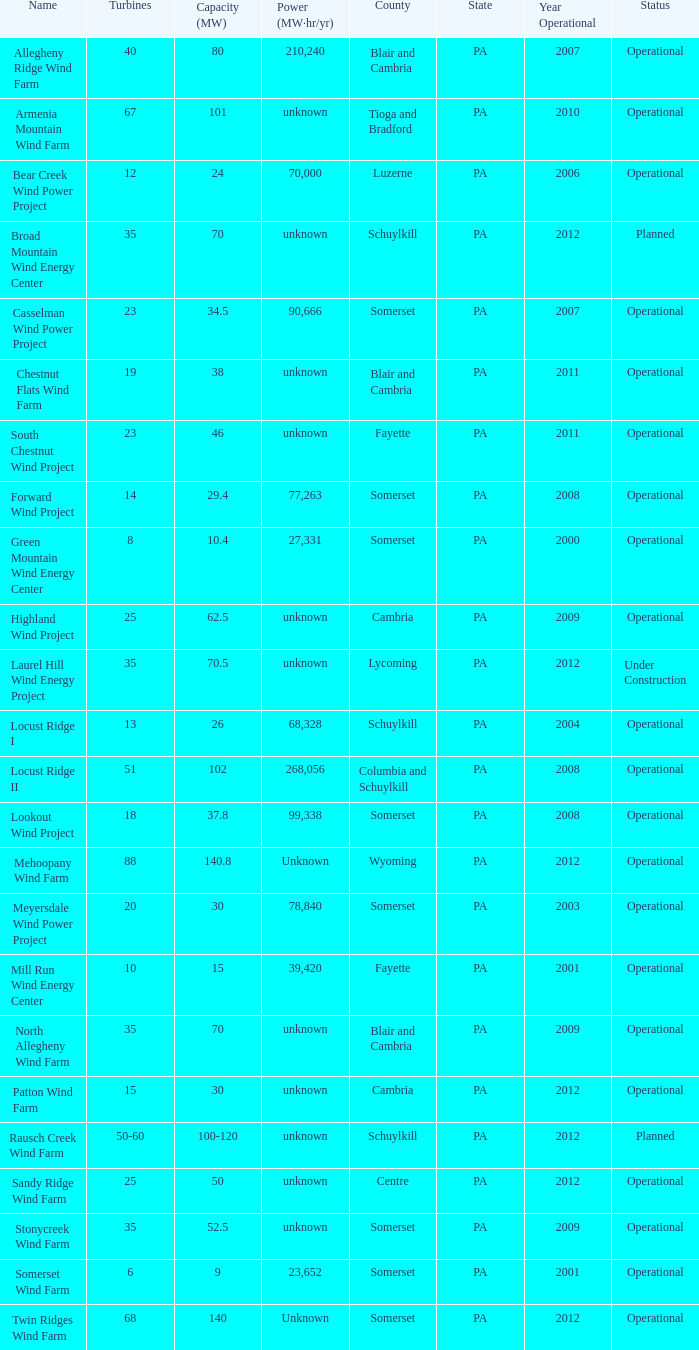What farm has a capacity of 70 and is operational? North Allegheny Wind Farm. 